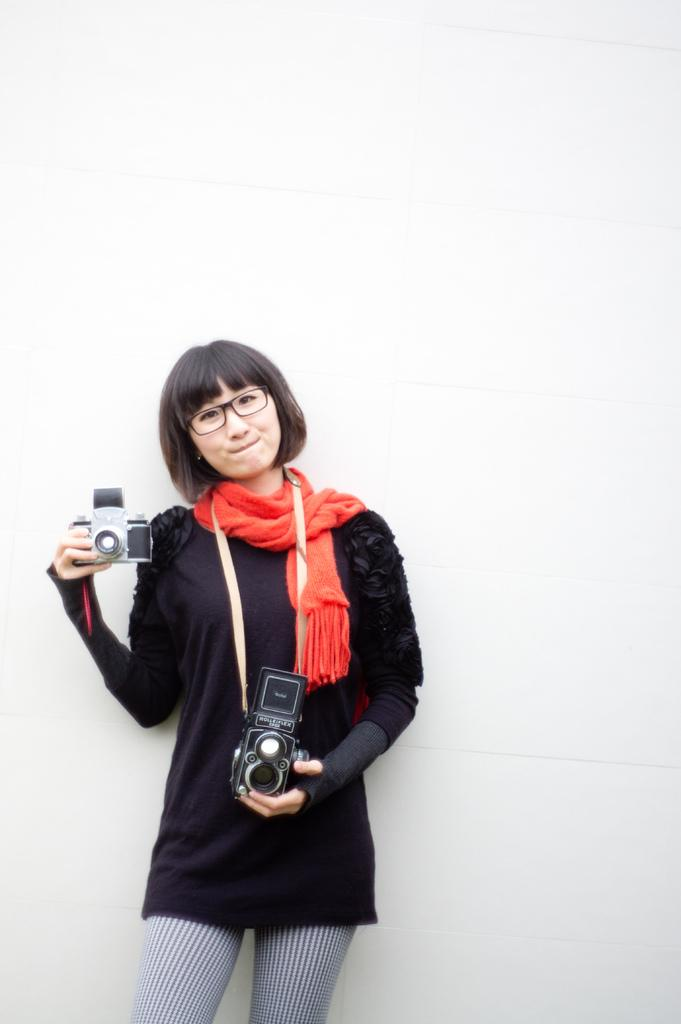What is the main subject of the image? The main subject of the image is a lady. What is the lady doing in the image? The lady is standing and holding cameras. What can be seen in the background of the image? There is a wall in the background of the image. Can you see any oil spills in the image? There is no mention of oil spills or any related elements in the image. Are there any cemeteries visible in the image? There is no mention of a cemetery or any related elements in the image. 